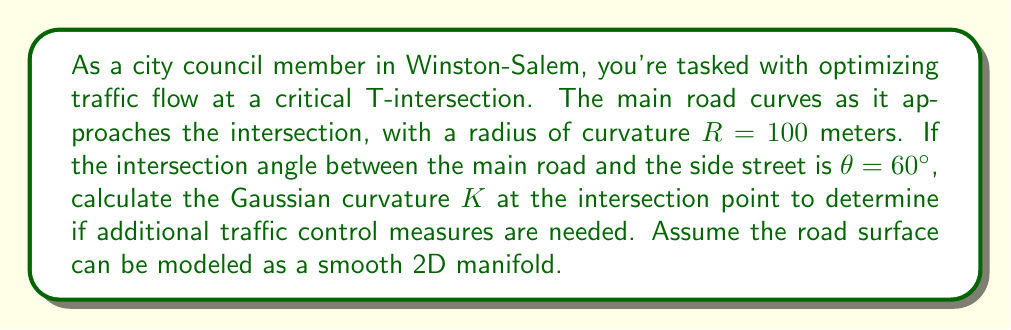Solve this math problem. To solve this problem, we'll follow these steps:

1) In differential geometry, the Gaussian curvature $K$ at a point on a surface is the product of the principal curvatures $\kappa_1$ and $\kappa_2$ at that point:

   $$K = \kappa_1 \kappa_2$$

2) For our road intersection, we can consider two directions:
   - Along the main road (curvature $\kappa_1$)
   - Perpendicular to the main road (curvature $\kappa_2$)

3) For the main road, the curvature is the inverse of the radius:

   $$\kappa_1 = \frac{1}{R} = \frac{1}{100} = 0.01 \text{ m}^{-1}$$

4) For the perpendicular direction, we need to consider the angle of the intersection. The curvature in this direction can be approximated as:

   $$\kappa_2 = \frac{\sin \theta}{R}$$

   Where $\theta$ is the angle between the main road and the side street.

5) Calculate $\kappa_2$:

   $$\kappa_2 = \frac{\sin 60°}{100} = \frac{\sqrt{3}/2}{100} \approx 0.00866 \text{ m}^{-1}$$

6) Now we can calculate the Gaussian curvature:

   $$K = \kappa_1 \kappa_2 = 0.01 \times 0.00866 = 0.0000866 \text{ m}^{-2}$$
Answer: $$K = 8.66 \times 10^{-5} \text{ m}^{-2}$$ 